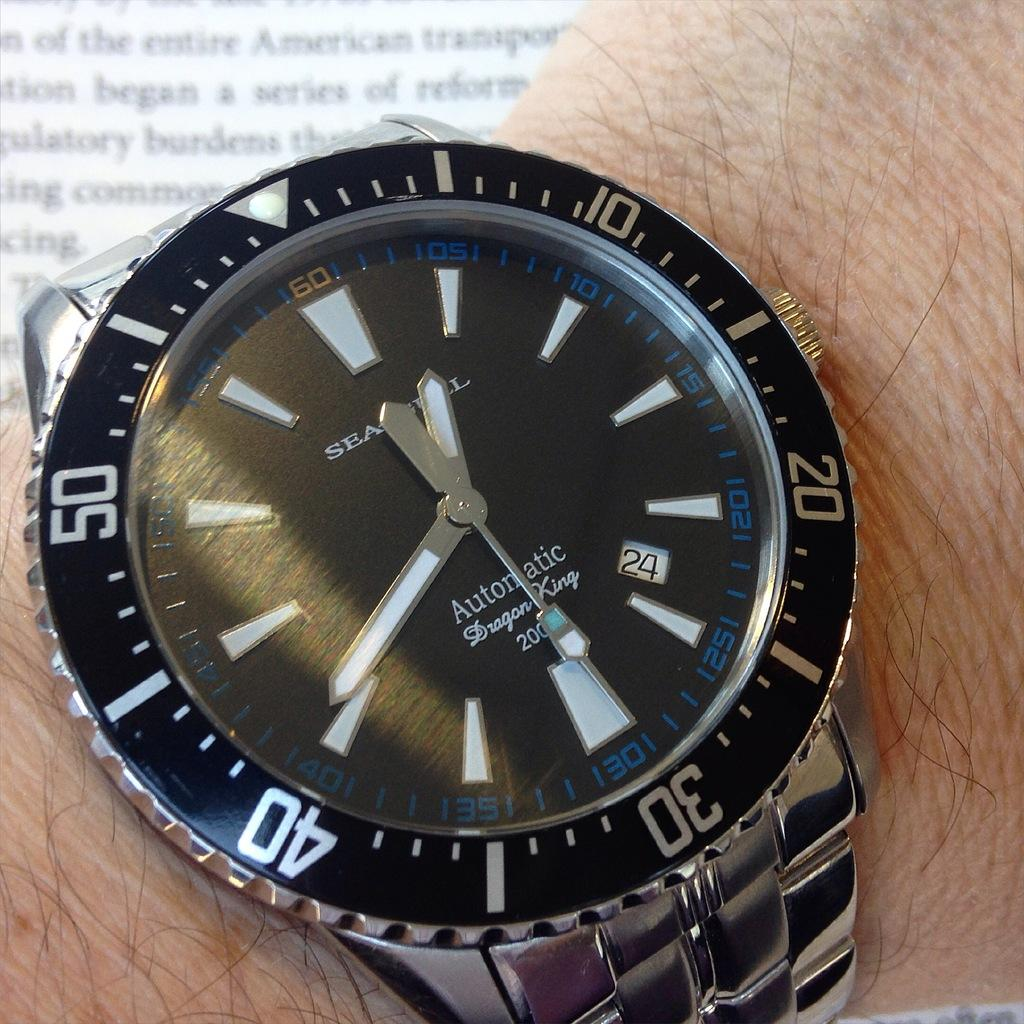<image>
Describe the image concisely. A watch that says "Dragon King" on the face has a blue and white second hand. 